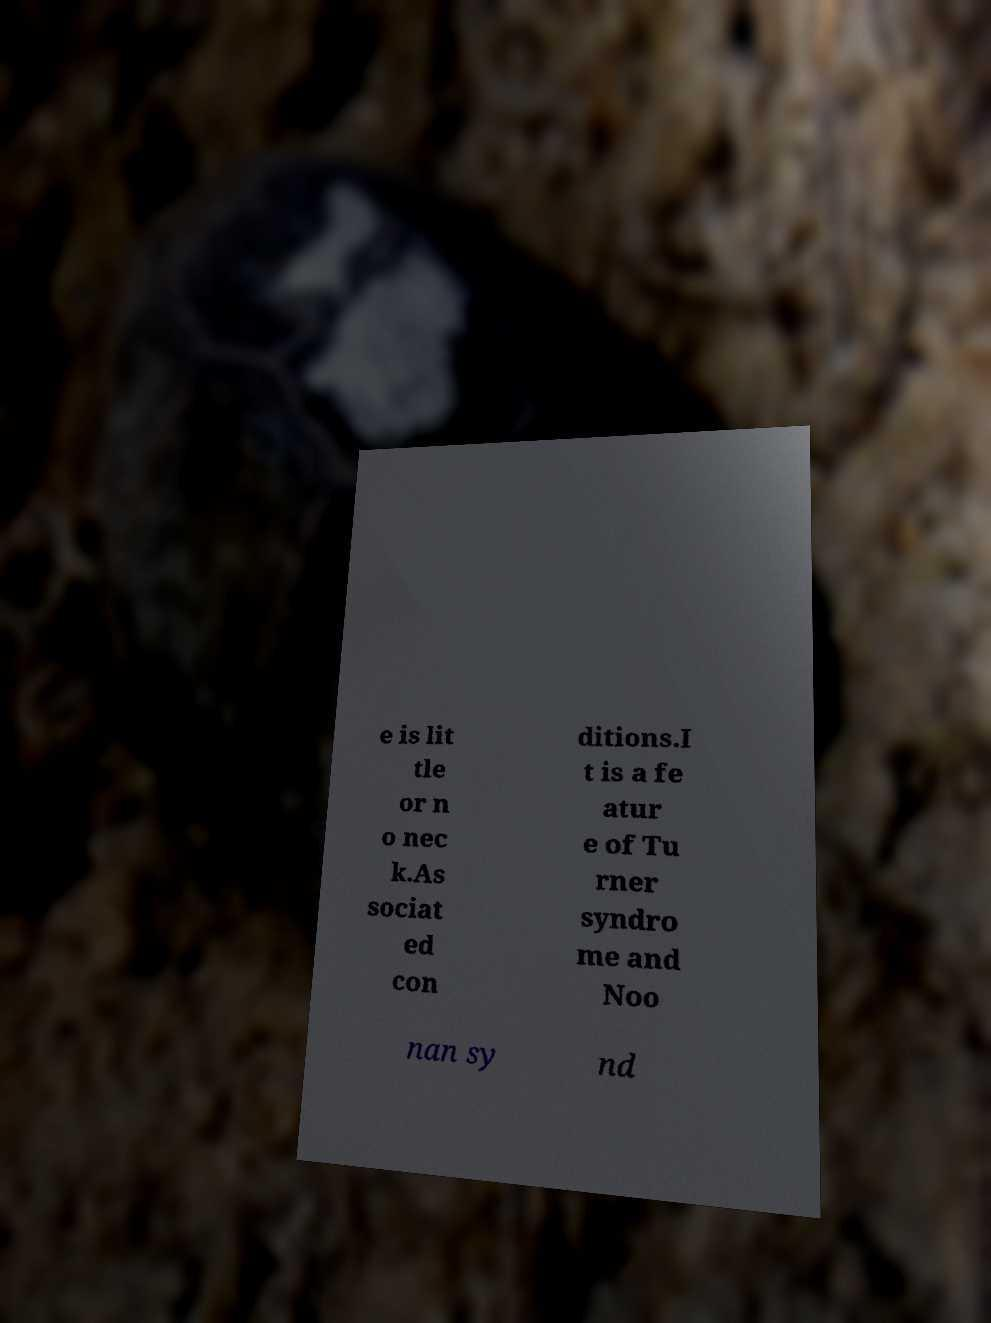Could you assist in decoding the text presented in this image and type it out clearly? e is lit tle or n o nec k.As sociat ed con ditions.I t is a fe atur e of Tu rner syndro me and Noo nan sy nd 